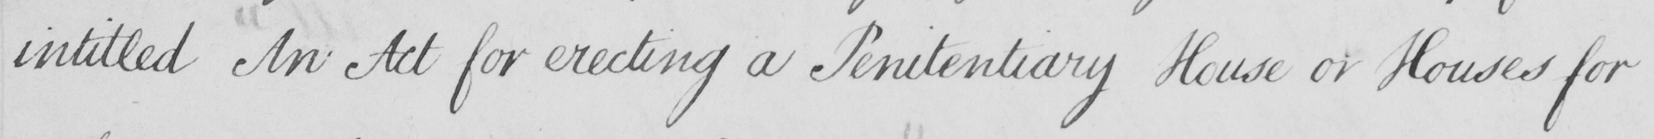Can you read and transcribe this handwriting? intitled An Act for erecting a Penitentiary House or Houses for 